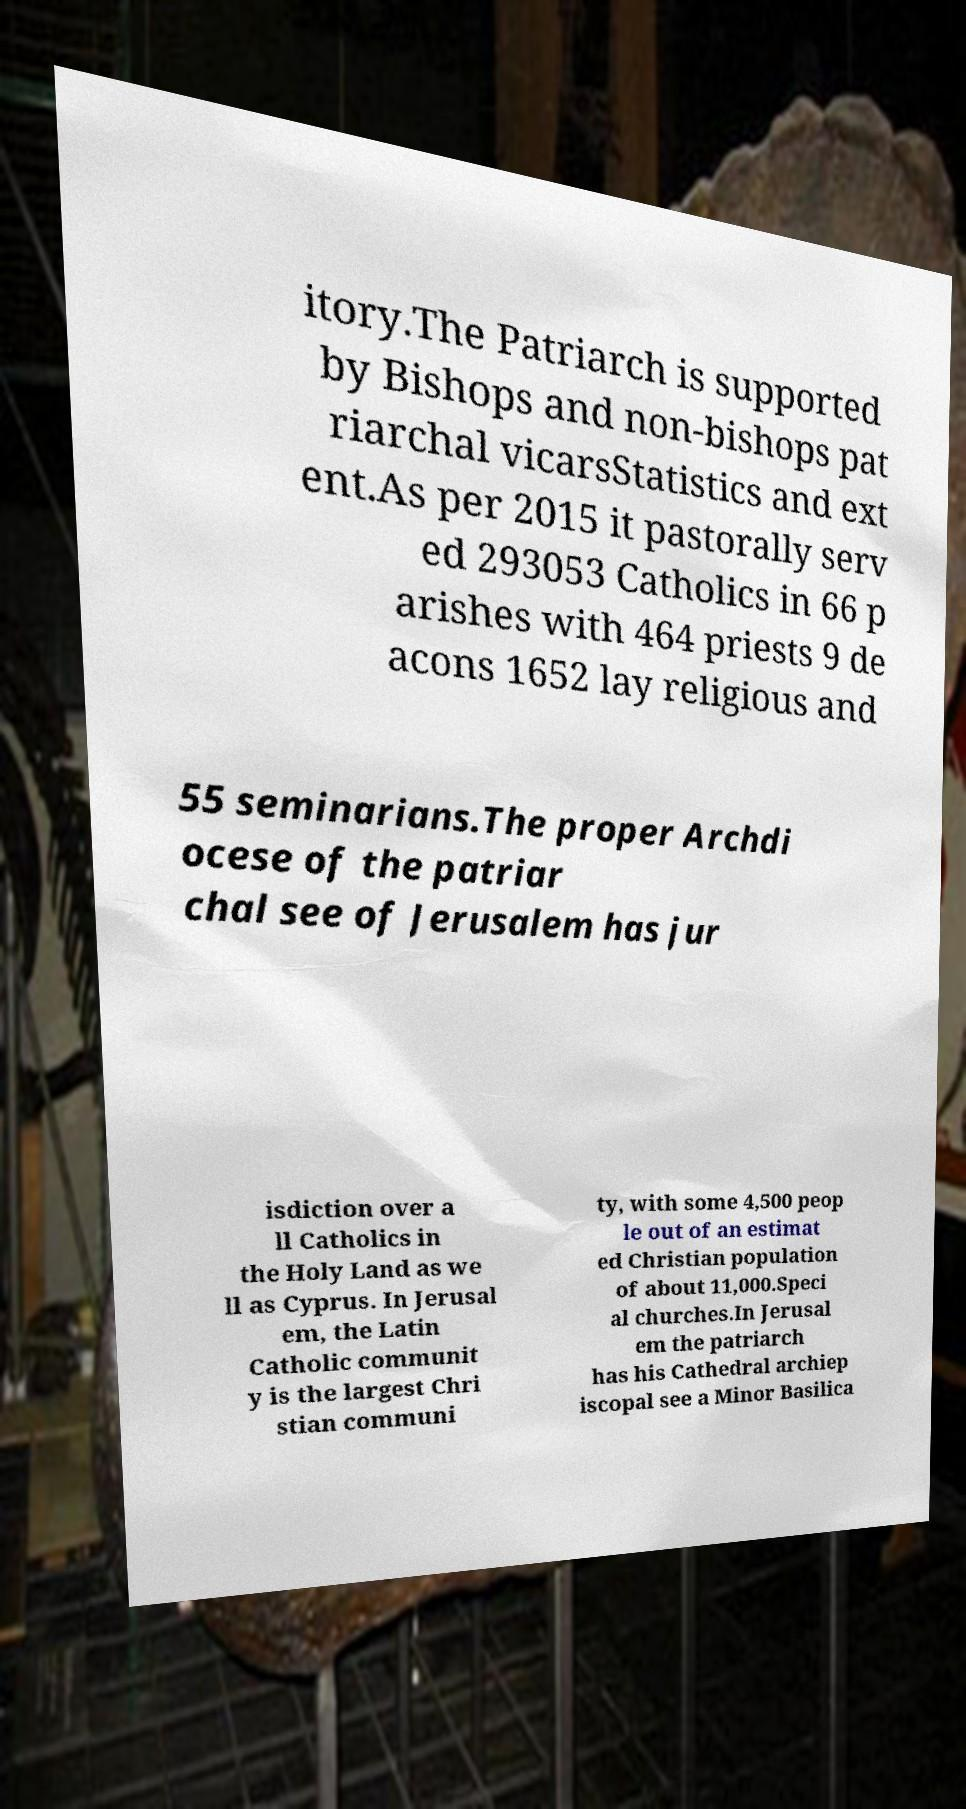Can you read and provide the text displayed in the image?This photo seems to have some interesting text. Can you extract and type it out for me? itory.The Patriarch is supported by Bishops and non-bishops pat riarchal vicarsStatistics and ext ent.As per 2015 it pastorally serv ed 293053 Catholics in 66 p arishes with 464 priests 9 de acons 1652 lay religious and 55 seminarians.The proper Archdi ocese of the patriar chal see of Jerusalem has jur isdiction over a ll Catholics in the Holy Land as we ll as Cyprus. In Jerusal em, the Latin Catholic communit y is the largest Chri stian communi ty, with some 4,500 peop le out of an estimat ed Christian population of about 11,000.Speci al churches.In Jerusal em the patriarch has his Cathedral archiep iscopal see a Minor Basilica 